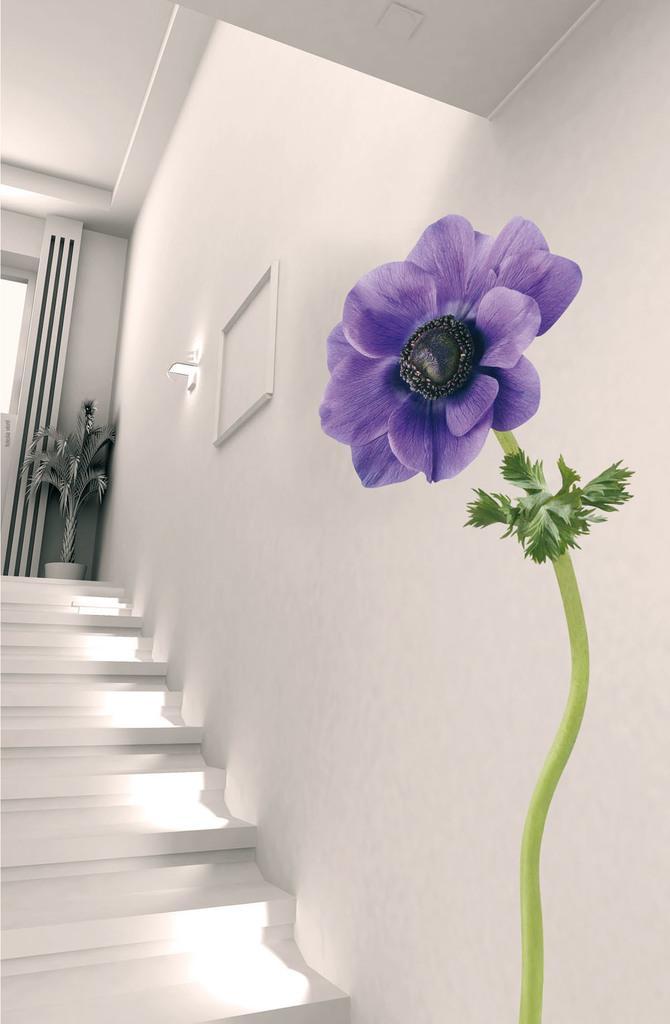How would you summarize this image in a sentence or two? This image consists of stairs. There is light in the middle. 